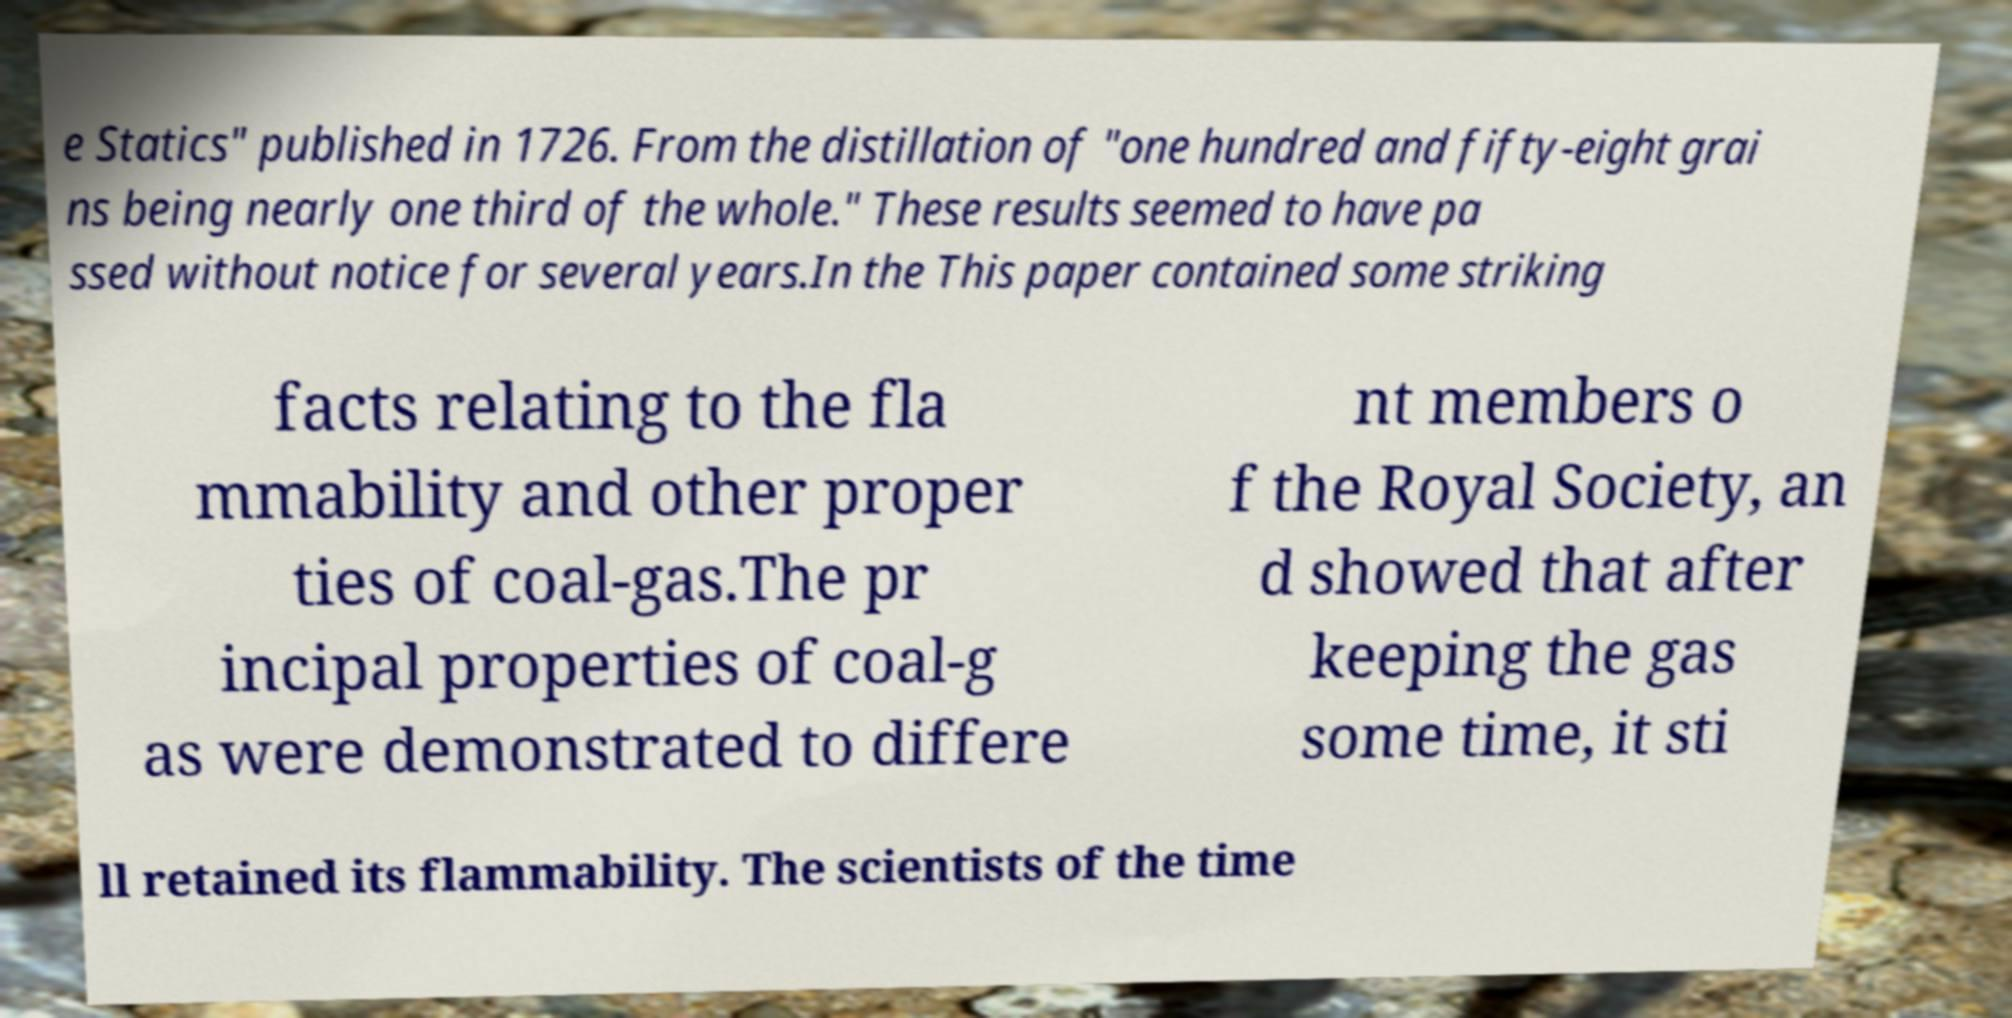Please read and relay the text visible in this image. What does it say? e Statics" published in 1726. From the distillation of "one hundred and fifty-eight grai ns being nearly one third of the whole." These results seemed to have pa ssed without notice for several years.In the This paper contained some striking facts relating to the fla mmability and other proper ties of coal-gas.The pr incipal properties of coal-g as were demonstrated to differe nt members o f the Royal Society, an d showed that after keeping the gas some time, it sti ll retained its flammability. The scientists of the time 